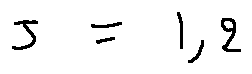Convert formula to latex. <formula><loc_0><loc_0><loc_500><loc_500>j = 1 , 2</formula> 